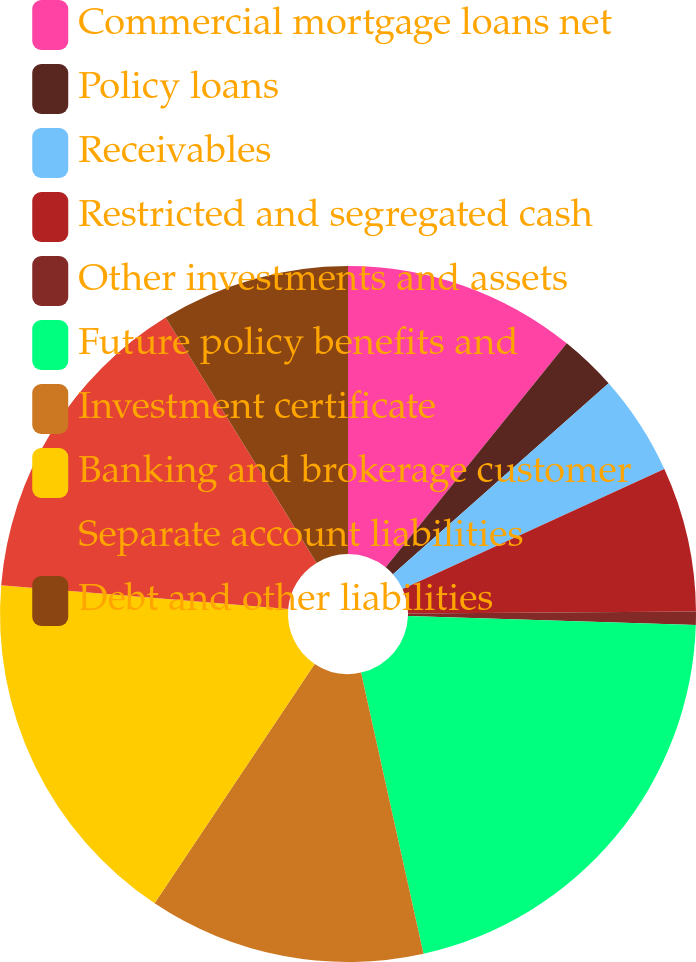Convert chart. <chart><loc_0><loc_0><loc_500><loc_500><pie_chart><fcel>Commercial mortgage loans net<fcel>Policy loans<fcel>Receivables<fcel>Restricted and segregated cash<fcel>Other investments and assets<fcel>Future policy benefits and<fcel>Investment certificate<fcel>Banking and brokerage customer<fcel>Separate account liabilities<fcel>Debt and other liabilities<nl><fcel>10.82%<fcel>2.65%<fcel>4.69%<fcel>6.73%<fcel>0.61%<fcel>21.02%<fcel>12.86%<fcel>16.94%<fcel>14.9%<fcel>8.78%<nl></chart> 